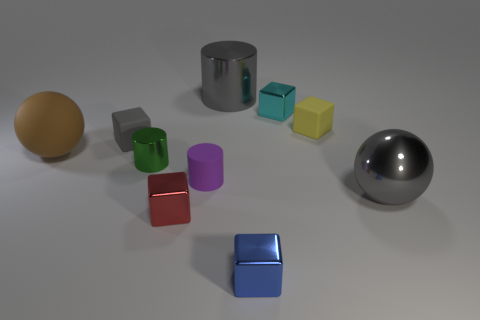Subtract all gray cubes. How many cubes are left? 4 Subtract all tiny yellow rubber blocks. How many blocks are left? 4 Subtract all purple cubes. Subtract all green cylinders. How many cubes are left? 5 Subtract all balls. How many objects are left? 8 Subtract 0 green cubes. How many objects are left? 10 Subtract all big gray metal things. Subtract all big blue matte cylinders. How many objects are left? 8 Add 1 small purple matte things. How many small purple matte things are left? 2 Add 7 small yellow shiny spheres. How many small yellow shiny spheres exist? 7 